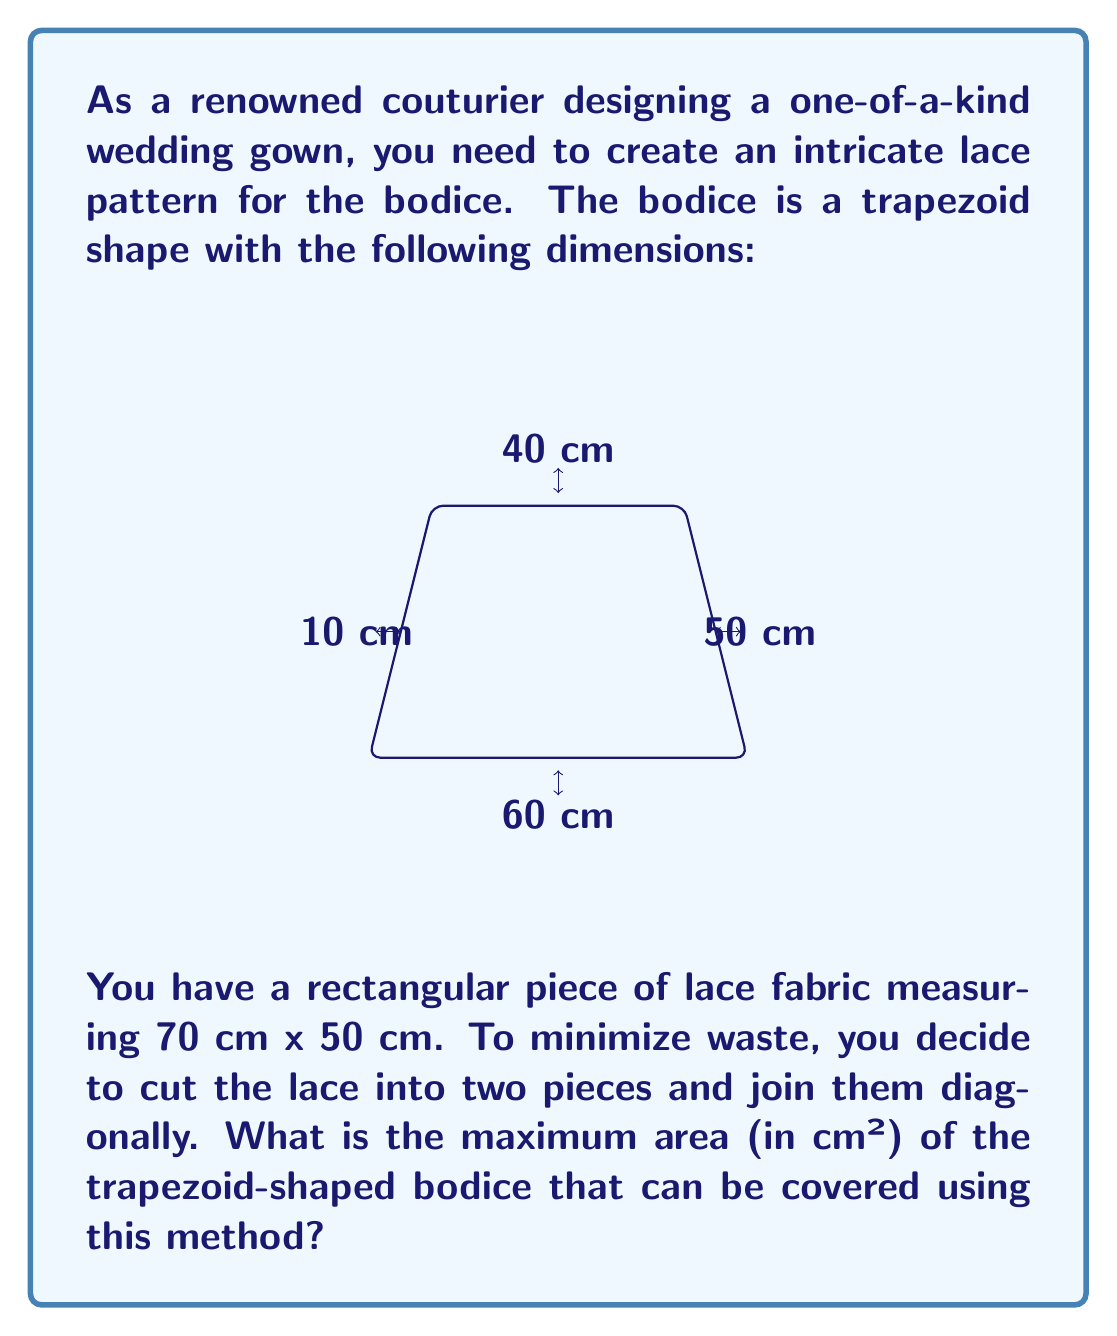Could you help me with this problem? Let's approach this step-by-step:

1) First, we need to calculate the area of the trapezoid-shaped bodice:
   Area of trapezoid = $\frac{1}{2}(b_1 + b_2)h$
   where $b_1 = 60$ cm, $b_2 = 10$ cm, and $h = 40$ cm
   
   Area = $\frac{1}{2}(60 + 10) \times 40 = 1400$ cm²

2) Now, let's consider the lace fabric. We need to cut it diagonally to create two triangles.

3) The diagonal of the rectangle can be calculated using the Pythagorean theorem:
   $d = \sqrt{70^2 + 50^2} = \sqrt{4900 + 2500} = \sqrt{7400} \approx 86.02$ cm

4) The area of each triangle will be:
   $A_{triangle} = \frac{1}{2} \times 70 \times 50 = 1750$ cm²

5) To cover the bodice most efficiently, we need to align the diagonal cut with the diagonal of the trapezoid.

6) The diagonal of the trapezoid can be calculated:
   $d_{trapezoid} = \sqrt{40^2 + 40^2} = 40\sqrt{2} \approx 56.57$ cm

7) Since the diagonal of our lace triangles (86.02 cm) is longer than the diagonal of the trapezoid (56.57 cm), we can cover the entire trapezoid area.

Therefore, the maximum area of the trapezoid-shaped bodice that can be covered is its full area: 1400 cm².
Answer: 1400 cm² 